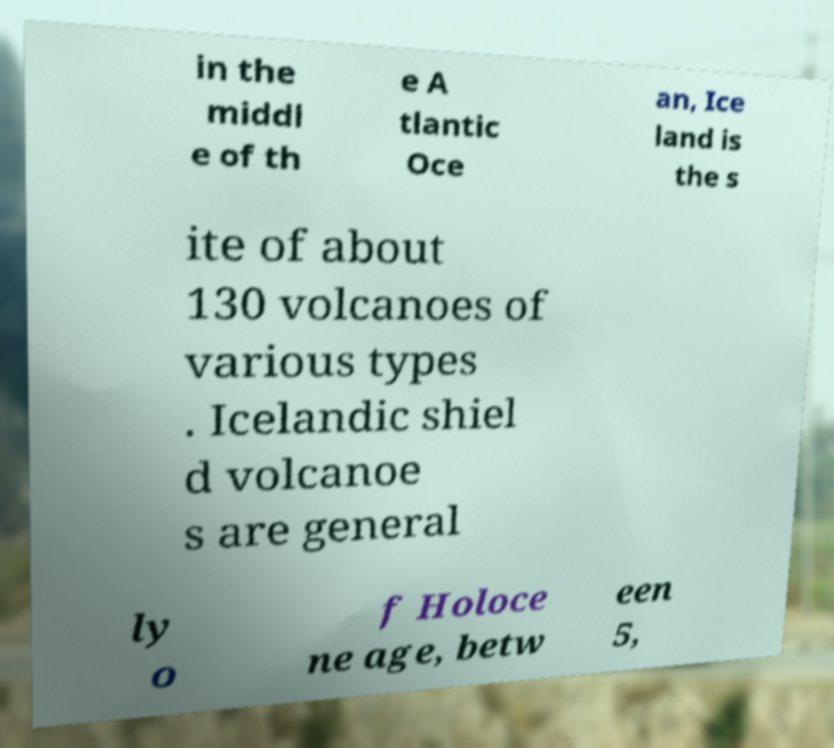Could you assist in decoding the text presented in this image and type it out clearly? in the middl e of th e A tlantic Oce an, Ice land is the s ite of about 130 volcanoes of various types . Icelandic shiel d volcanoe s are general ly o f Holoce ne age, betw een 5, 